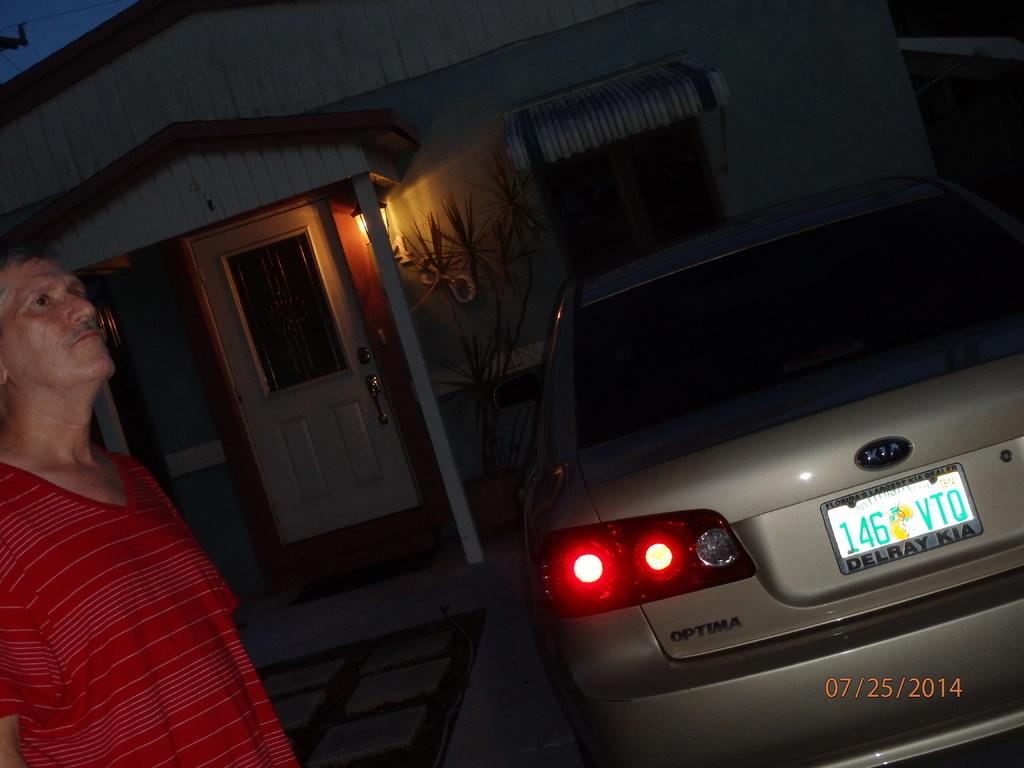<image>
Write a terse but informative summary of the picture. Car licence plate which says 146VTQ on it. 